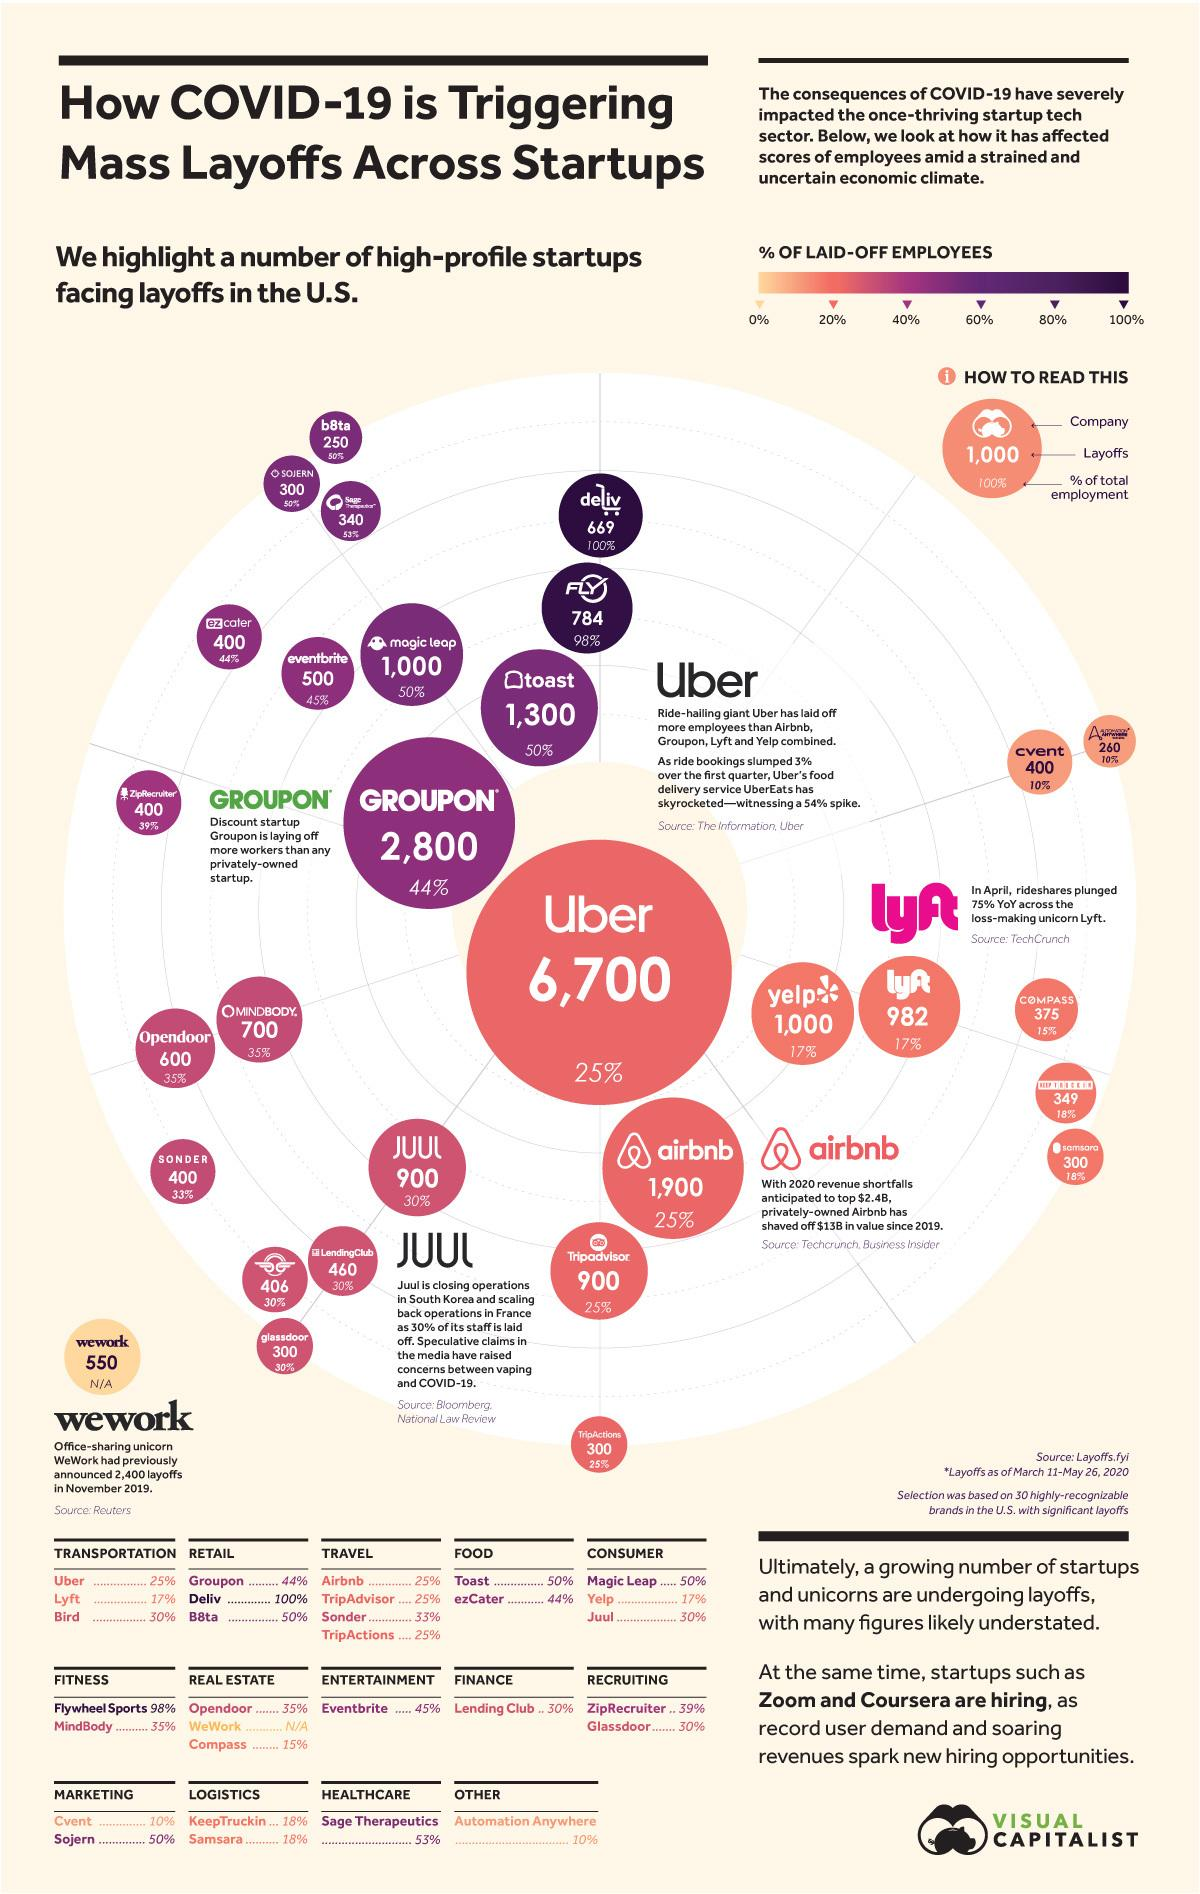Identify some key points in this picture. Uber is the company that has fired the highest number of employees. According to a recent study, approximately 50% of employees are fired by toast. Uber fired approximately 6,700 employees. According to Yelp, 83% of its employees have not been fired. According to recent reports, approximately 50% of employees at Magic Leap have been fired. 